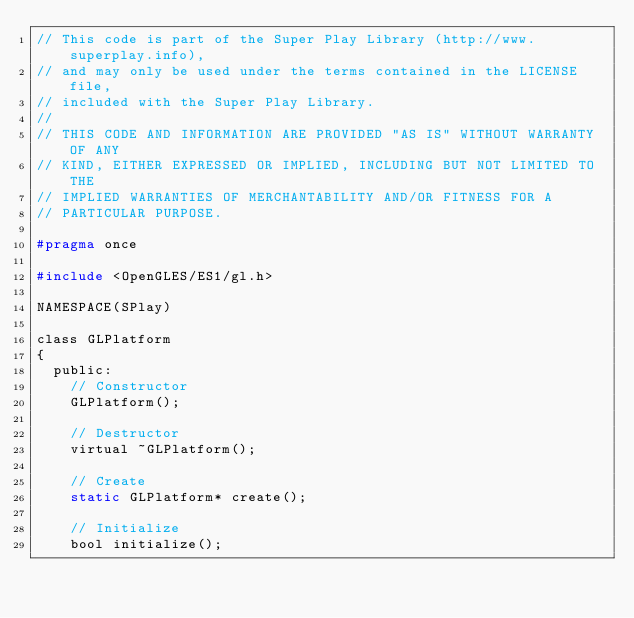Convert code to text. <code><loc_0><loc_0><loc_500><loc_500><_C_>// This code is part of the Super Play Library (http://www.superplay.info),
// and may only be used under the terms contained in the LICENSE file,
// included with the Super Play Library.
//
// THIS CODE AND INFORMATION ARE PROVIDED "AS IS" WITHOUT WARRANTY OF ANY 
// KIND, EITHER EXPRESSED OR IMPLIED, INCLUDING BUT NOT LIMITED TO THE
// IMPLIED WARRANTIES OF MERCHANTABILITY AND/OR FITNESS FOR A
// PARTICULAR PURPOSE.

#pragma once

#include <OpenGLES/ES1/gl.h>

NAMESPACE(SPlay)

class GLPlatform
{
	public:
		// Constructor
		GLPlatform();

		// Destructor
		virtual ~GLPlatform();

		// Create
		static GLPlatform* create();

		// Initialize
		bool initialize();
</code> 